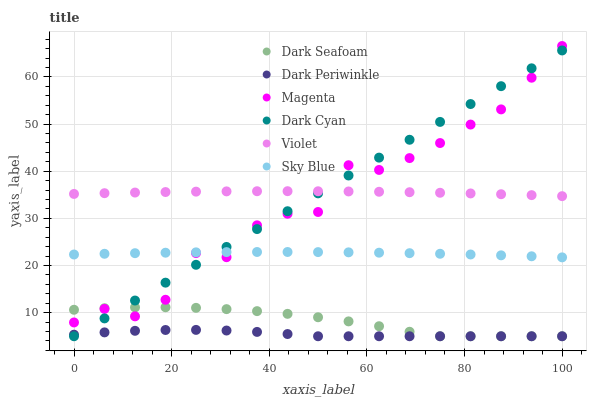Does Dark Periwinkle have the minimum area under the curve?
Answer yes or no. Yes. Does Violet have the maximum area under the curve?
Answer yes or no. Yes. Does Dark Cyan have the minimum area under the curve?
Answer yes or no. No. Does Dark Cyan have the maximum area under the curve?
Answer yes or no. No. Is Dark Cyan the smoothest?
Answer yes or no. Yes. Is Magenta the roughest?
Answer yes or no. Yes. Is Violet the smoothest?
Answer yes or no. No. Is Violet the roughest?
Answer yes or no. No. Does Dark Seafoam have the lowest value?
Answer yes or no. Yes. Does Violet have the lowest value?
Answer yes or no. No. Does Magenta have the highest value?
Answer yes or no. Yes. Does Violet have the highest value?
Answer yes or no. No. Is Dark Seafoam less than Violet?
Answer yes or no. Yes. Is Violet greater than Dark Seafoam?
Answer yes or no. Yes. Does Dark Cyan intersect Magenta?
Answer yes or no. Yes. Is Dark Cyan less than Magenta?
Answer yes or no. No. Is Dark Cyan greater than Magenta?
Answer yes or no. No. Does Dark Seafoam intersect Violet?
Answer yes or no. No. 